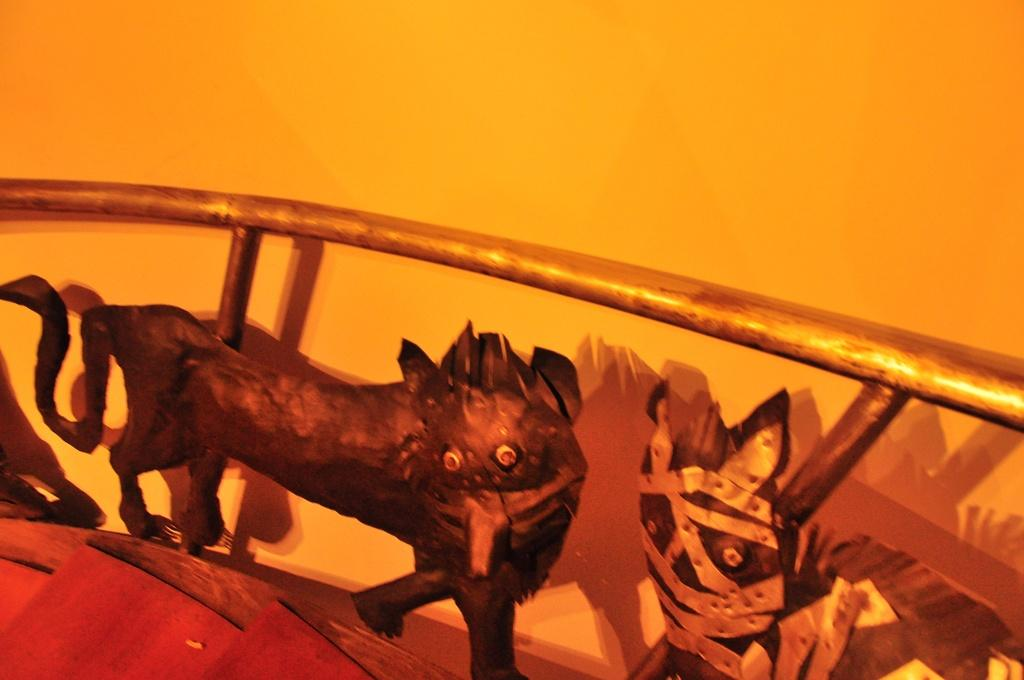What type of stairs can be seen in the image? There are wooden stairs in the image. What kind of artwork is present in the image? There are animal paintings in the image. How are the animal paintings attached to the wall? The animal paintings are fixed to metal rods. What can be seen behind the stairs and paintings in the image? There is a wall visible in the image. Where is the engine located in the image? There is no engine present in the image. How many kittens can be seen playing with the wooden stairs in the image? There are no kittens present in the image. 